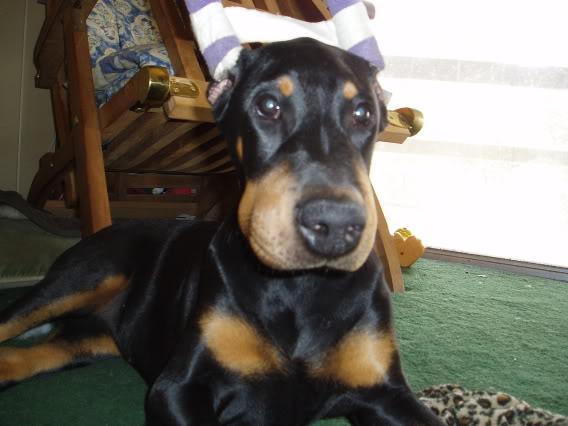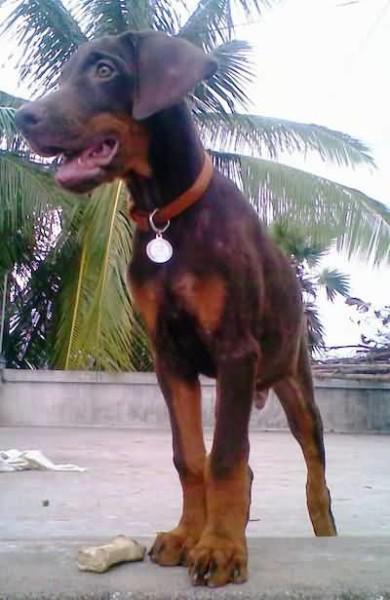The first image is the image on the left, the second image is the image on the right. Examine the images to the left and right. Is the description "There are exactly two dogs." accurate? Answer yes or no. Yes. The first image is the image on the left, the second image is the image on the right. Evaluate the accuracy of this statement regarding the images: "There is a total of two real dogs.". Is it true? Answer yes or no. Yes. 